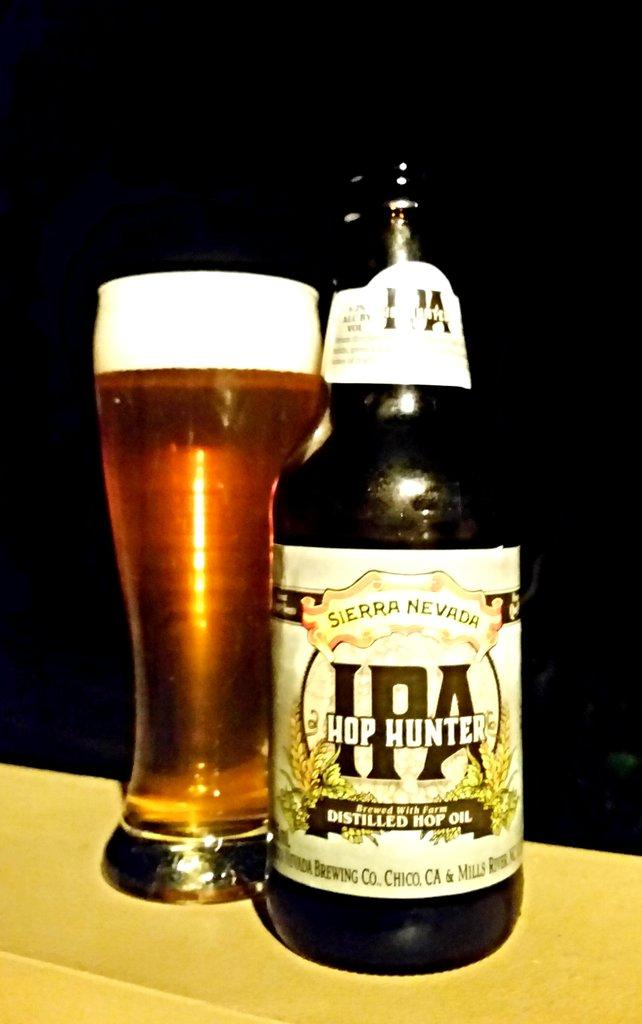Provide a one-sentence caption for the provided image. A bottle of IPA Hop Hunter is served in a tall glass. 